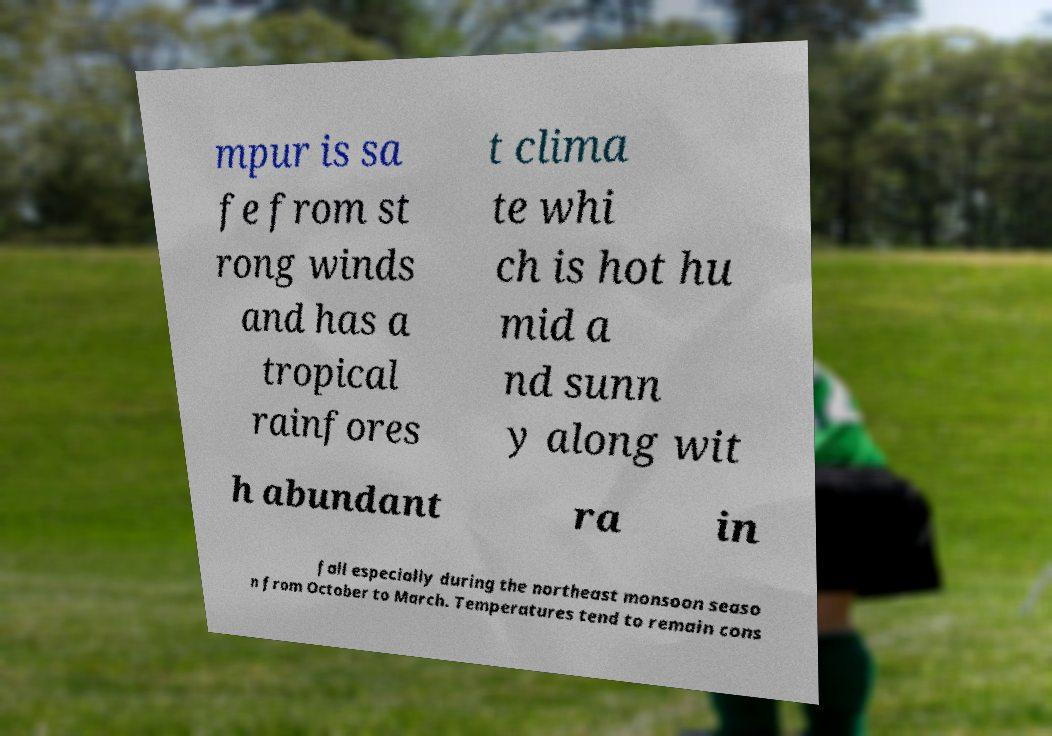For documentation purposes, I need the text within this image transcribed. Could you provide that? mpur is sa fe from st rong winds and has a tropical rainfores t clima te whi ch is hot hu mid a nd sunn y along wit h abundant ra in fall especially during the northeast monsoon seaso n from October to March. Temperatures tend to remain cons 